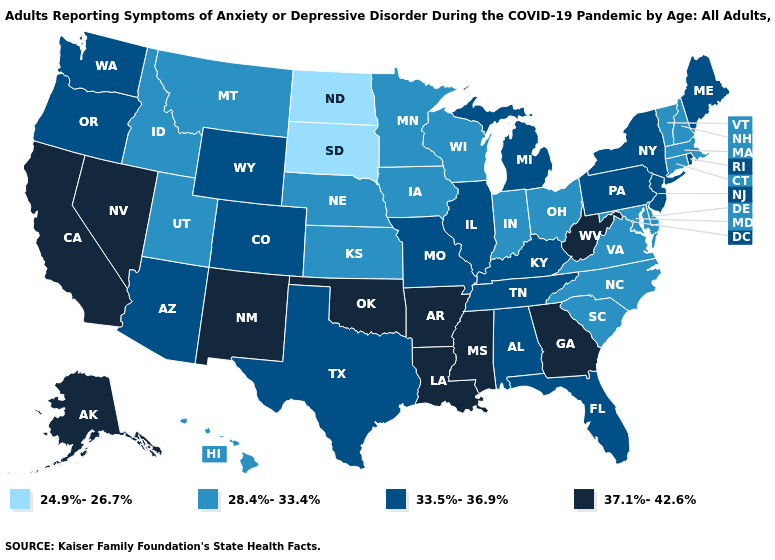Among the states that border Connecticut , does Massachusetts have the lowest value?
Answer briefly. Yes. What is the highest value in states that border Montana?
Quick response, please. 33.5%-36.9%. Does Wisconsin have a lower value than Massachusetts?
Short answer required. No. Is the legend a continuous bar?
Write a very short answer. No. Among the states that border Arizona , does California have the lowest value?
Keep it brief. No. Does Nevada have a higher value than Indiana?
Concise answer only. Yes. Does South Dakota have a lower value than North Dakota?
Be succinct. No. Name the states that have a value in the range 37.1%-42.6%?
Keep it brief. Alaska, Arkansas, California, Georgia, Louisiana, Mississippi, Nevada, New Mexico, Oklahoma, West Virginia. Name the states that have a value in the range 24.9%-26.7%?
Be succinct. North Dakota, South Dakota. Does West Virginia have the same value as Oklahoma?
Short answer required. Yes. Which states have the lowest value in the South?
Give a very brief answer. Delaware, Maryland, North Carolina, South Carolina, Virginia. Among the states that border North Carolina , which have the highest value?
Answer briefly. Georgia. Does the first symbol in the legend represent the smallest category?
Keep it brief. Yes. Among the states that border Wyoming , does Colorado have the lowest value?
Quick response, please. No. Name the states that have a value in the range 24.9%-26.7%?
Give a very brief answer. North Dakota, South Dakota. 